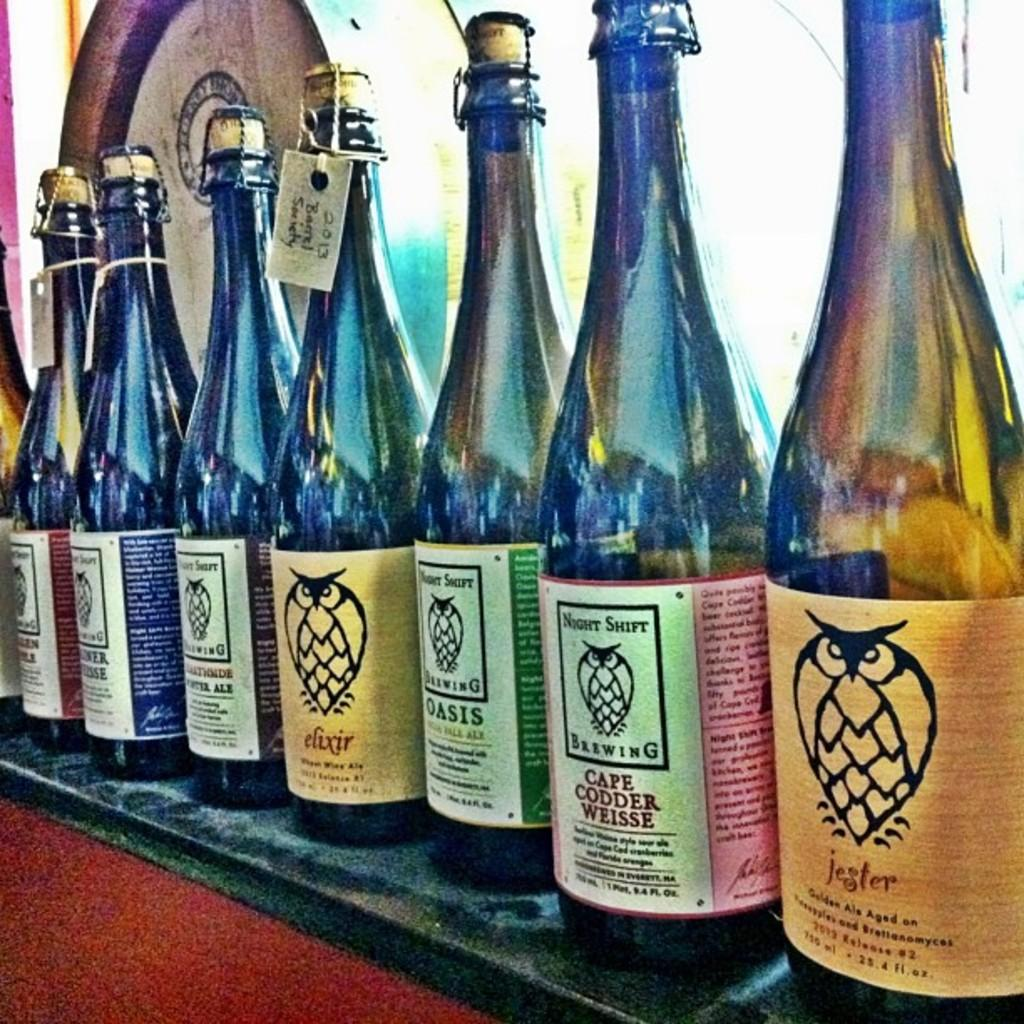<image>
Provide a brief description of the given image. Bottles of beer on display with the first bottle saying "Jester". 